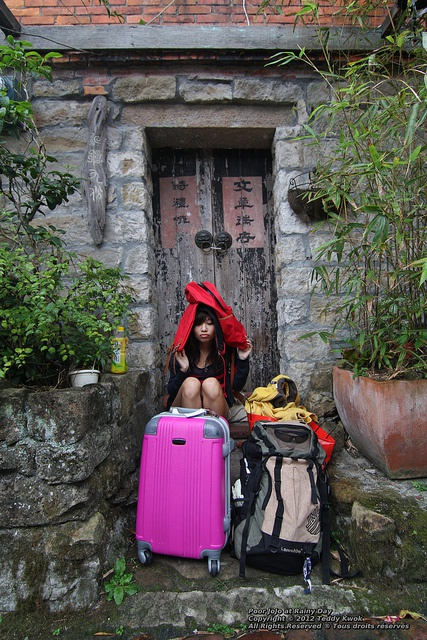Describe the objects in this image and their specific colors. I can see potted plant in black, gray, darkgreen, and darkgray tones, backpack in black, gray, and darkgray tones, suitcase in black, magenta, and purple tones, potted plant in black, gray, and darkgreen tones, and people in black, gray, maroon, and brown tones in this image. 